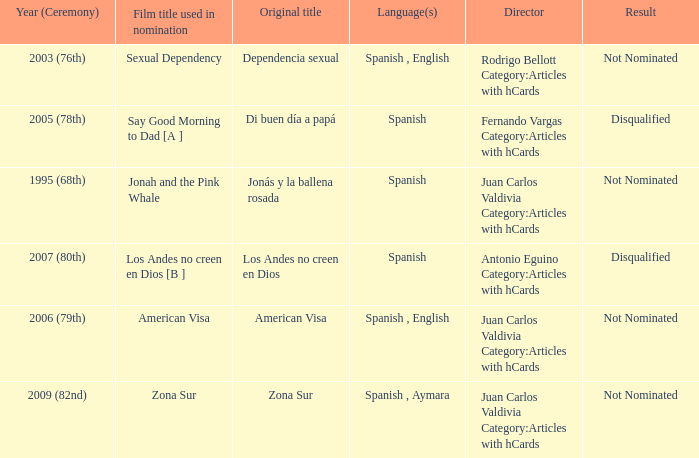What is Dependencia Sexual's film title that was used in its nomination? Sexual Dependency. 